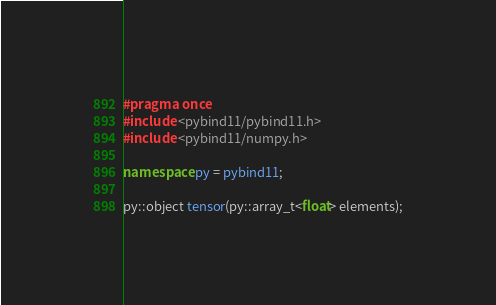Convert code to text. <code><loc_0><loc_0><loc_500><loc_500><_C++_>#pragma once
#include <pybind11/pybind11.h>
#include <pybind11/numpy.h>

namespace py = pybind11;

py::object tensor(py::array_t<float> elements);
</code> 